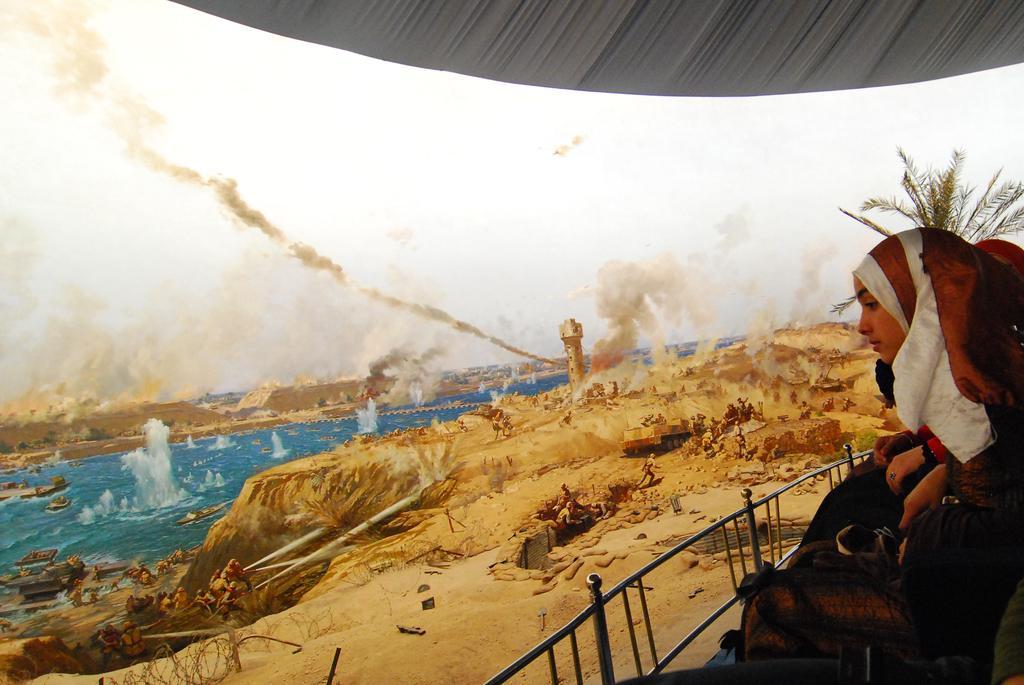How would you summarize this image in a sentence or two? In this picture there is a woman, tree and there are bags and there is a railing on the right side of the image. On the left side of the image there are boats on the water and there are group of people and there is a tower and smoke. At the top there is sky. At the bottom there is sand. 